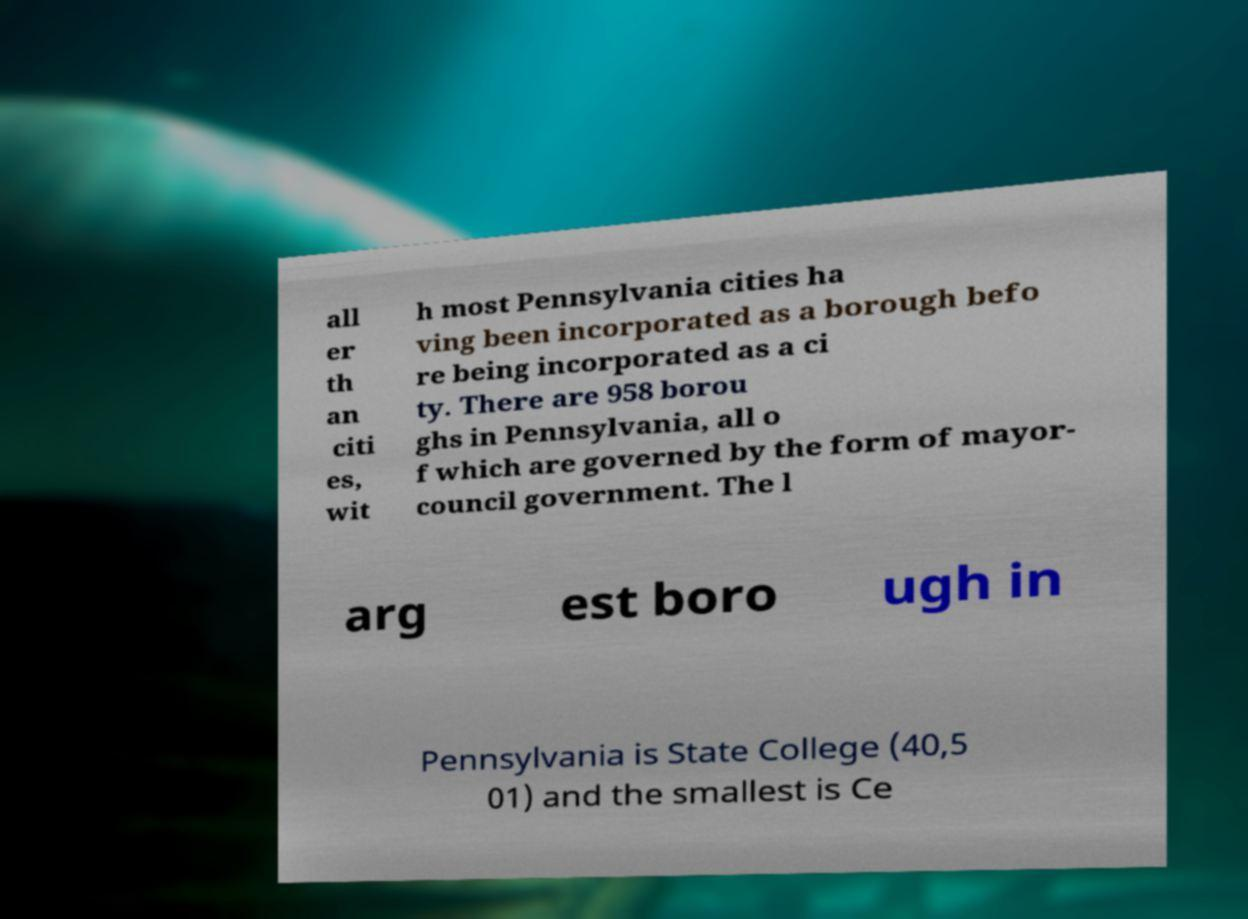What messages or text are displayed in this image? I need them in a readable, typed format. all er th an citi es, wit h most Pennsylvania cities ha ving been incorporated as a borough befo re being incorporated as a ci ty. There are 958 borou ghs in Pennsylvania, all o f which are governed by the form of mayor- council government. The l arg est boro ugh in Pennsylvania is State College (40,5 01) and the smallest is Ce 